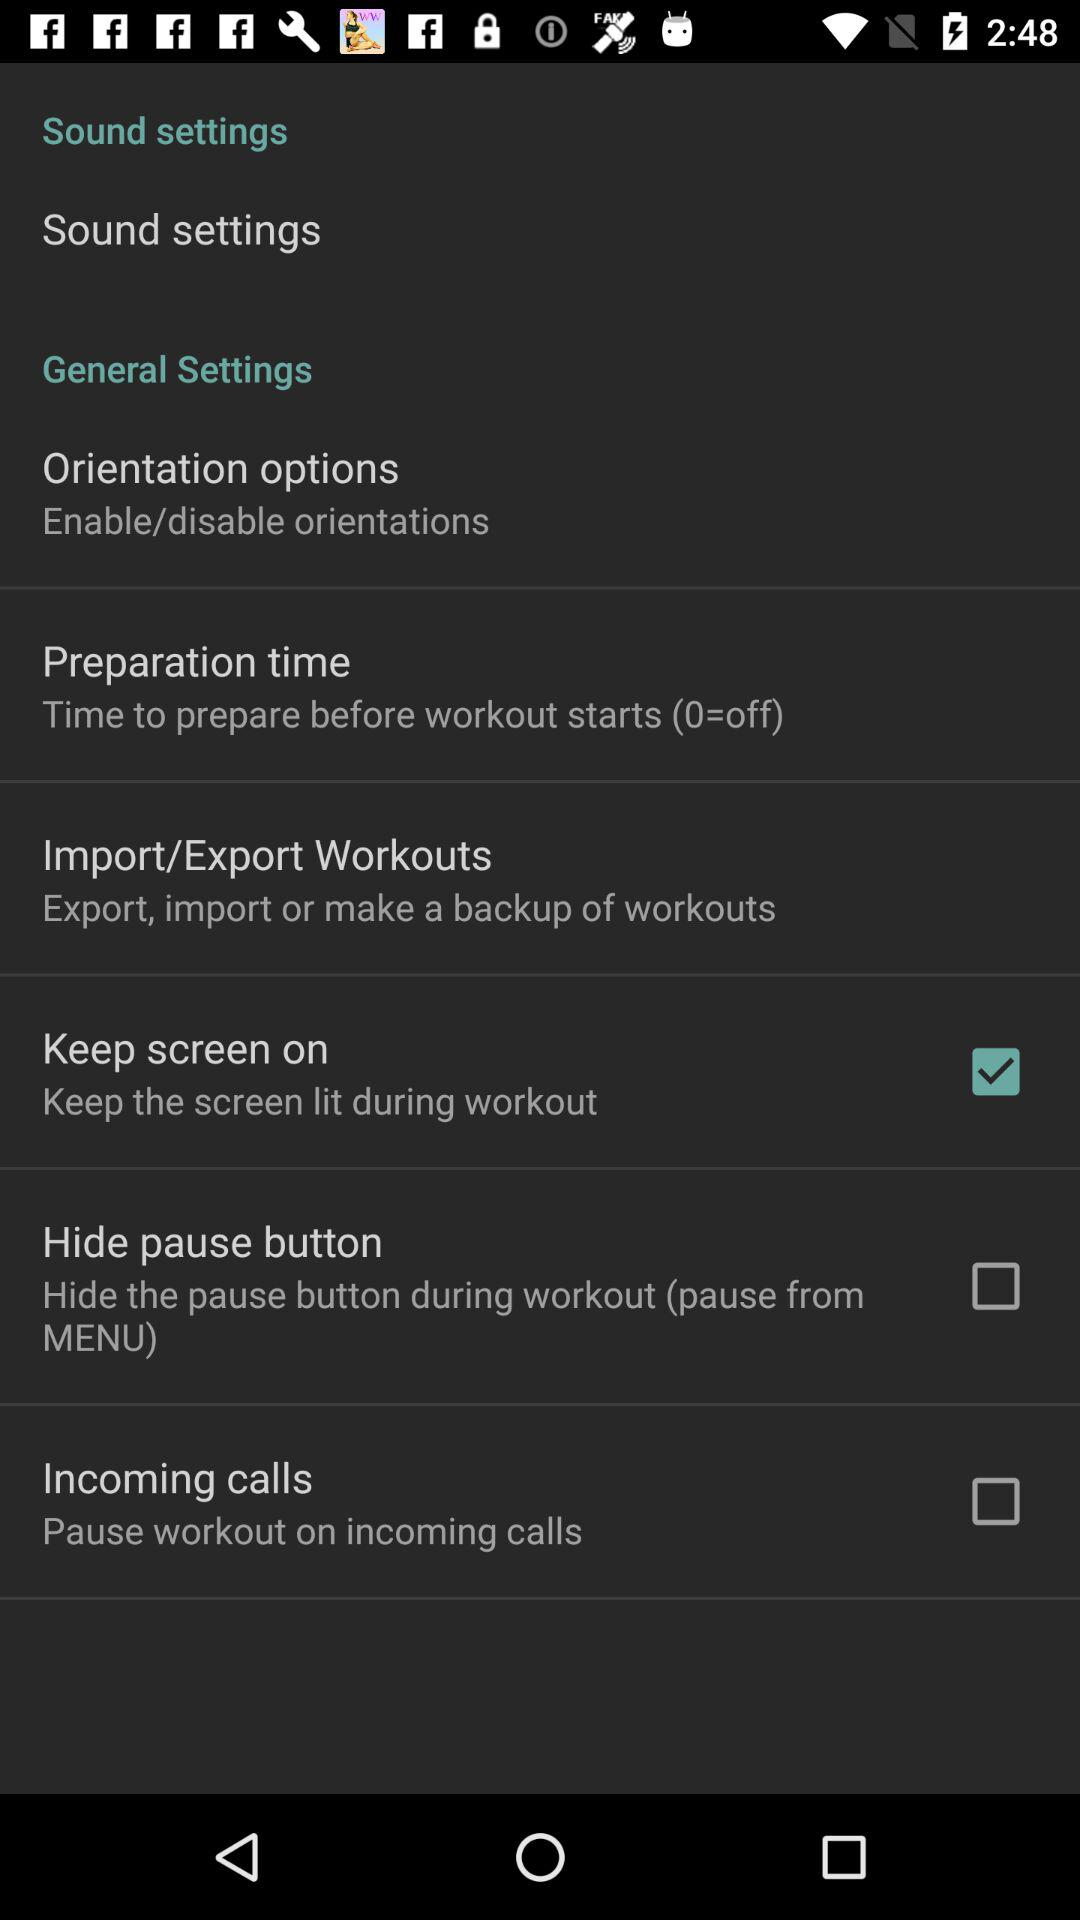Which option is clicked? The clicked option is "Keep screen on". 